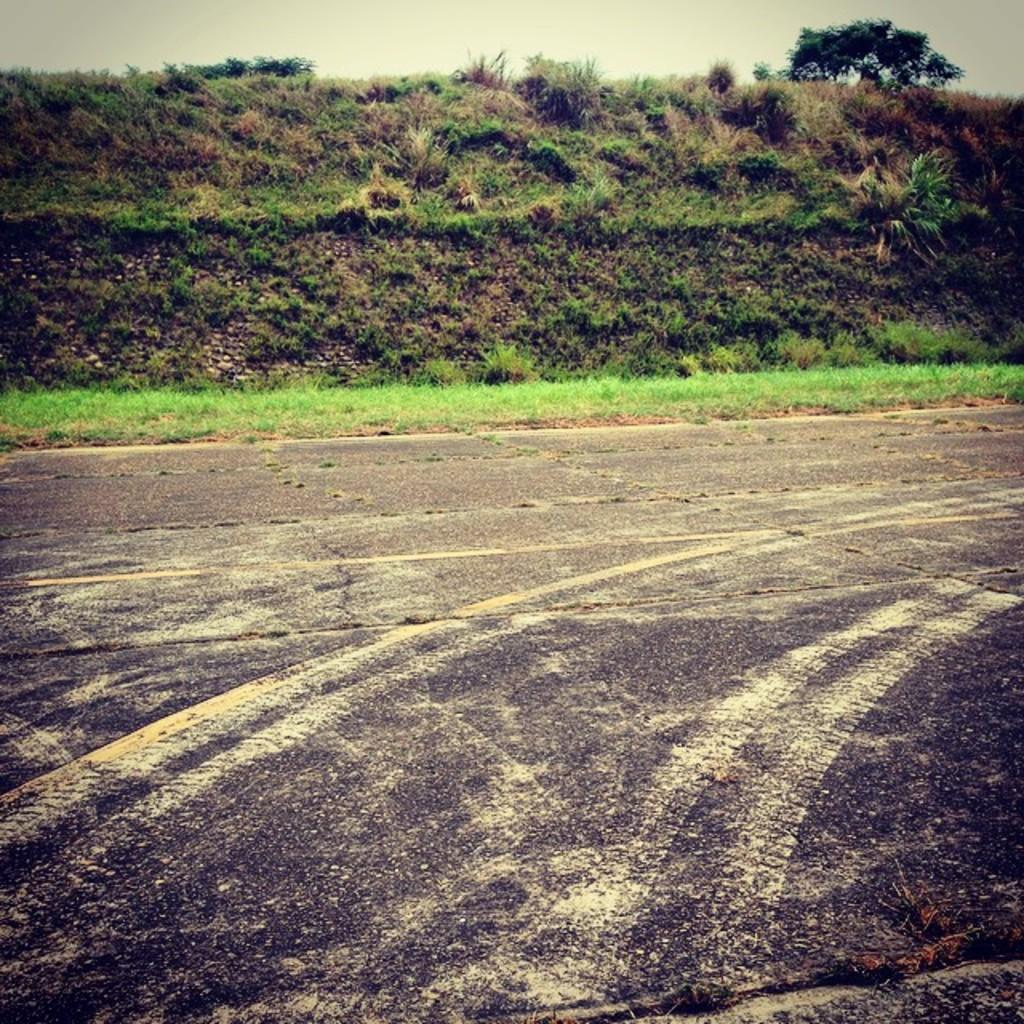What type of vegetation can be seen in the image? There is grass and plants in the image. What other natural element is present in the image? There is a tree in the image. What can be seen in the background of the image? The sky is visible in the background of the image. What type of creature can be seen working in the office in the image? There is no office or creature present in the image; it features natural elements such as grass, plants, and a tree. 